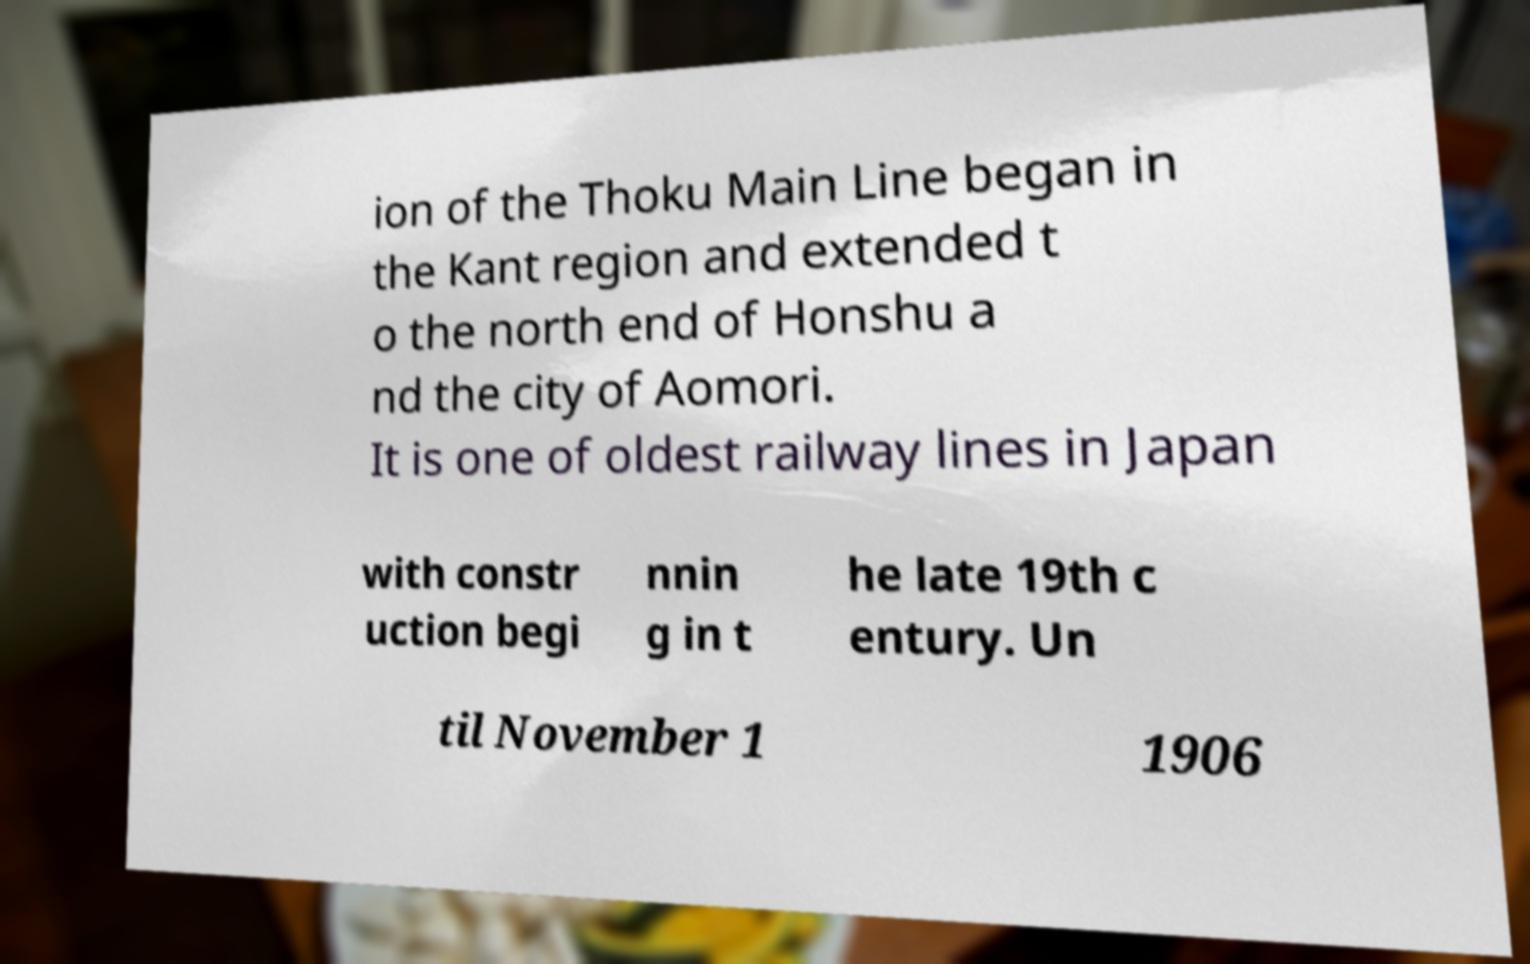Can you accurately transcribe the text from the provided image for me? ion of the Thoku Main Line began in the Kant region and extended t o the north end of Honshu a nd the city of Aomori. It is one of oldest railway lines in Japan with constr uction begi nnin g in t he late 19th c entury. Un til November 1 1906 